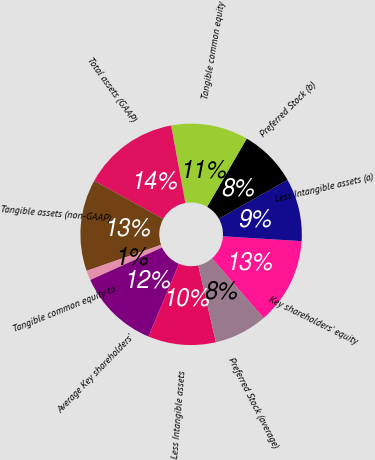Convert chart. <chart><loc_0><loc_0><loc_500><loc_500><pie_chart><fcel>Key shareholders' equity<fcel>Less Intangible assets (a)<fcel>Preferred Stock (b)<fcel>Tangible common equity<fcel>Total assets (GAAP)<fcel>Tangible assets (non-GAAP)<fcel>Tangible common equity to<fcel>Average Key shareholders'<fcel>Less Intangible assets<fcel>Preferred Stock (average)<nl><fcel>12.68%<fcel>9.15%<fcel>8.45%<fcel>11.27%<fcel>14.08%<fcel>13.38%<fcel>1.41%<fcel>11.97%<fcel>9.86%<fcel>7.75%<nl></chart> 